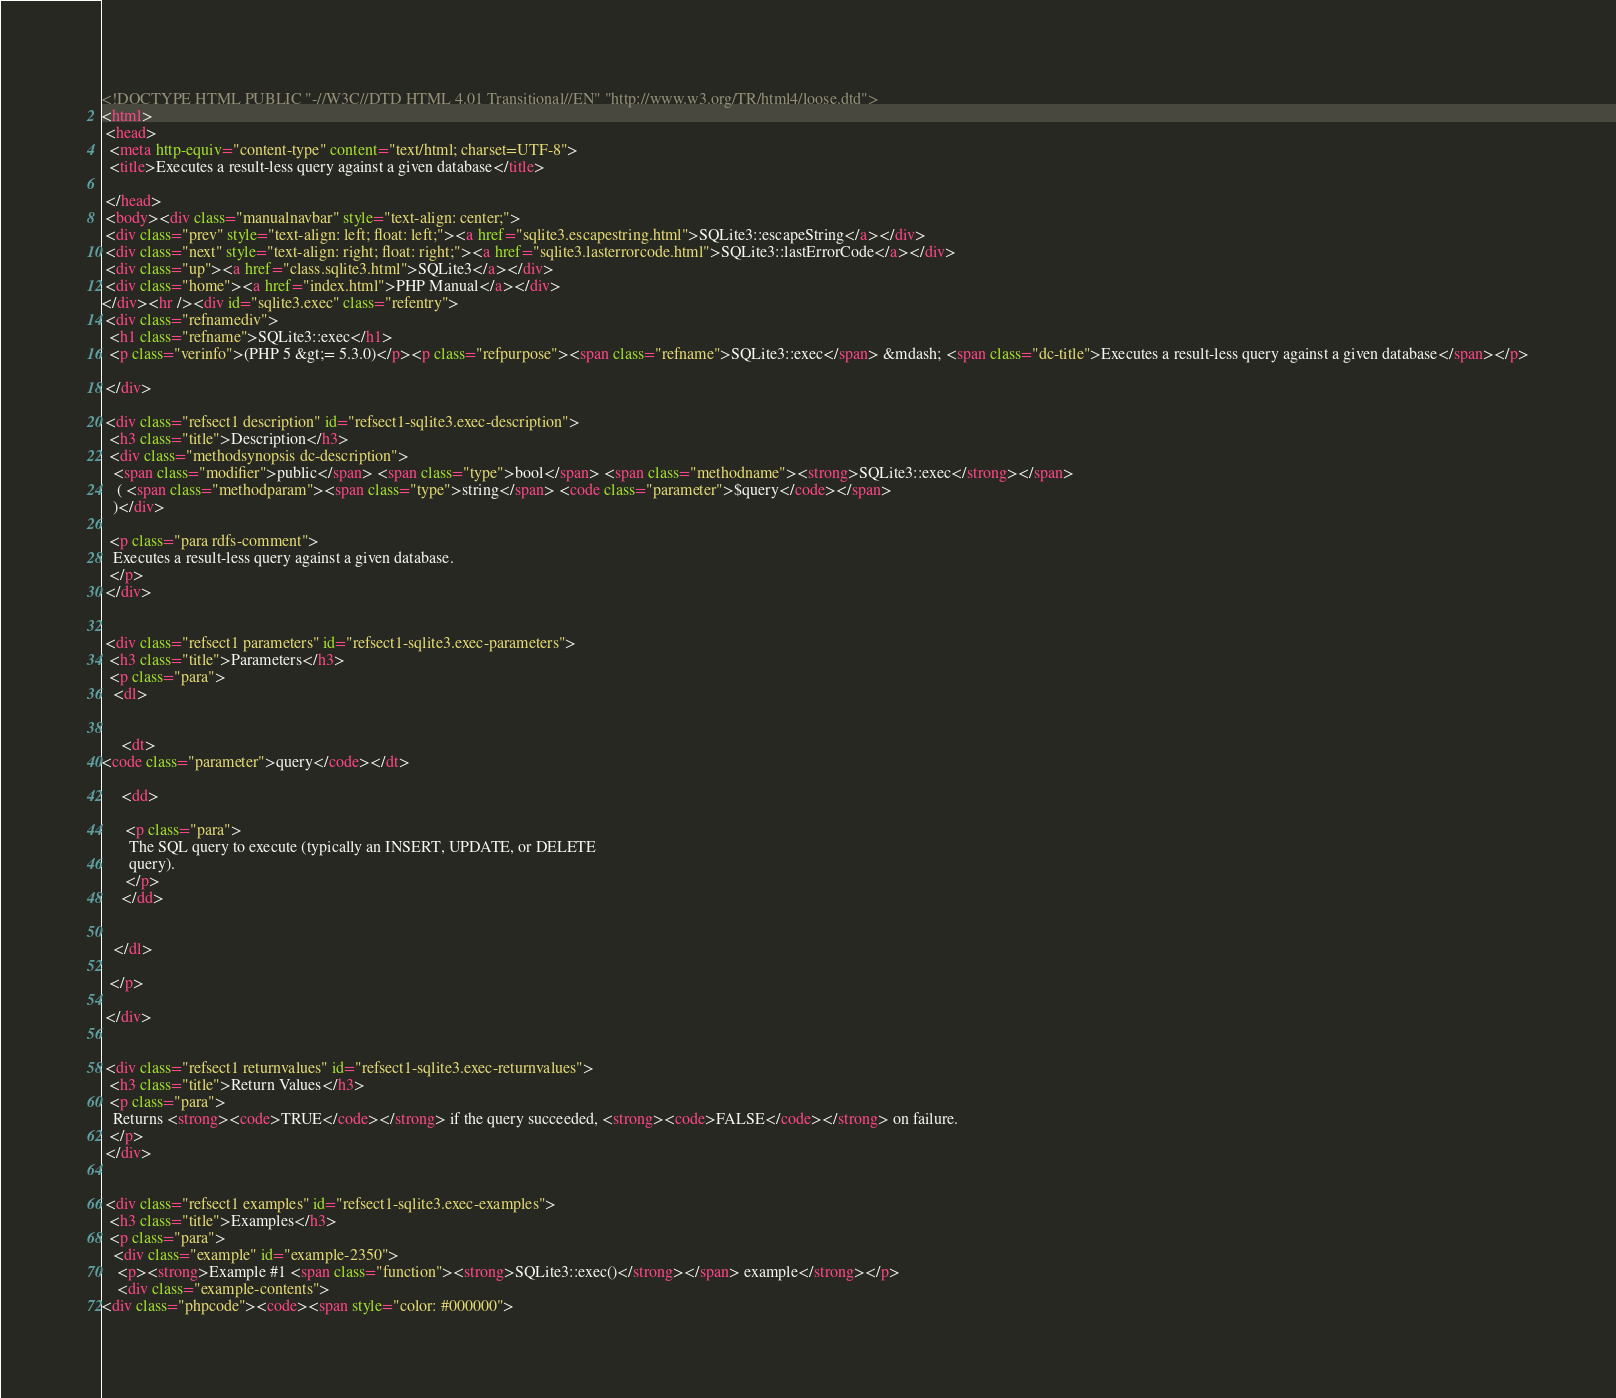Convert code to text. <code><loc_0><loc_0><loc_500><loc_500><_HTML_><!DOCTYPE HTML PUBLIC "-//W3C//DTD HTML 4.01 Transitional//EN" "http://www.w3.org/TR/html4/loose.dtd">
<html>
 <head>
  <meta http-equiv="content-type" content="text/html; charset=UTF-8">
  <title>Executes a result-less query against a given database</title>

 </head>
 <body><div class="manualnavbar" style="text-align: center;">
 <div class="prev" style="text-align: left; float: left;"><a href="sqlite3.escapestring.html">SQLite3::escapeString</a></div>
 <div class="next" style="text-align: right; float: right;"><a href="sqlite3.lasterrorcode.html">SQLite3::lastErrorCode</a></div>
 <div class="up"><a href="class.sqlite3.html">SQLite3</a></div>
 <div class="home"><a href="index.html">PHP Manual</a></div>
</div><hr /><div id="sqlite3.exec" class="refentry">
 <div class="refnamediv">
  <h1 class="refname">SQLite3::exec</h1>
  <p class="verinfo">(PHP 5 &gt;= 5.3.0)</p><p class="refpurpose"><span class="refname">SQLite3::exec</span> &mdash; <span class="dc-title">Executes a result-less query against a given database</span></p>

 </div>

 <div class="refsect1 description" id="refsect1-sqlite3.exec-description">
  <h3 class="title">Description</h3>
  <div class="methodsynopsis dc-description">
   <span class="modifier">public</span> <span class="type">bool</span> <span class="methodname"><strong>SQLite3::exec</strong></span>
    ( <span class="methodparam"><span class="type">string</span> <code class="parameter">$query</code></span>
   )</div>

  <p class="para rdfs-comment">
   Executes a result-less query against a given database.
  </p>
 </div>


 <div class="refsect1 parameters" id="refsect1-sqlite3.exec-parameters">
  <h3 class="title">Parameters</h3>
  <p class="para">
   <dl>

    
     <dt>
<code class="parameter">query</code></dt>

     <dd>

      <p class="para">
       The SQL query to execute (typically an INSERT, UPDATE, or DELETE
       query).
      </p>
     </dd>

    
   </dl>

  </p>

 </div>


 <div class="refsect1 returnvalues" id="refsect1-sqlite3.exec-returnvalues">
  <h3 class="title">Return Values</h3>
  <p class="para">
   Returns <strong><code>TRUE</code></strong> if the query succeeded, <strong><code>FALSE</code></strong> on failure.
  </p>
 </div>


 <div class="refsect1 examples" id="refsect1-sqlite3.exec-examples">
  <h3 class="title">Examples</h3>
  <p class="para">
   <div class="example" id="example-2350">
    <p><strong>Example #1 <span class="function"><strong>SQLite3::exec()</strong></span> example</strong></p>
    <div class="example-contents">
<div class="phpcode"><code><span style="color: #000000"></code> 